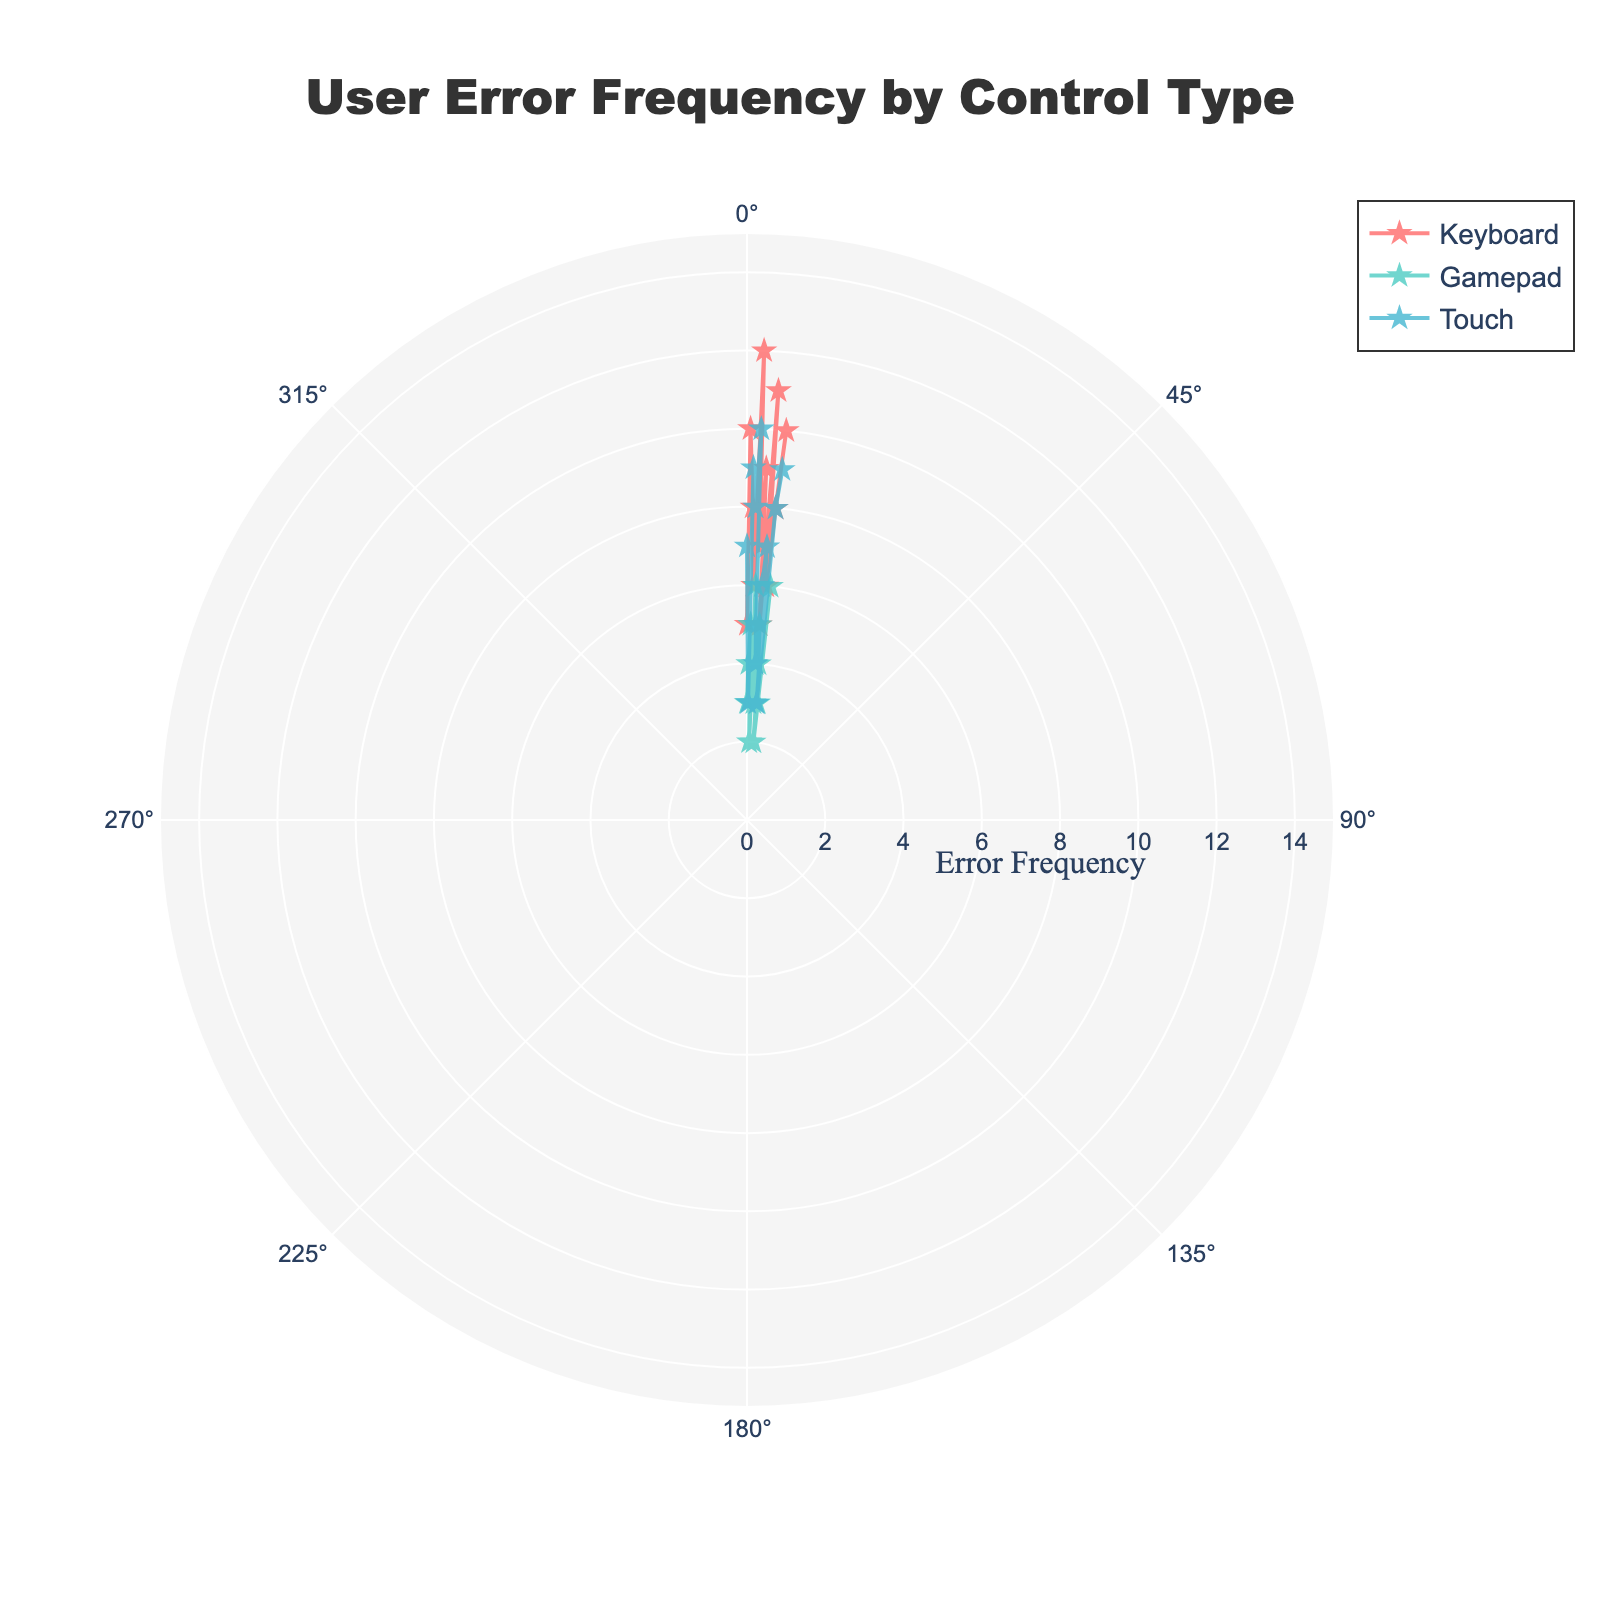What is the title of the figure? The title is usually placed prominently at the top center of the figure. It provides a quick summary of the chart's content.
Answer: User Error Frequency by Control Type Which control type has the highest error frequency at 90 degrees? To find this, look at the data points situated at the 90-degree mark for each control type. The highest value among these is the one with the most errors. Keyboard: 6, Gamepad: 2, Touch: 8.
Answer: Touch How many error frequency points are plotted for the Gamepad control type? Identify the color or symbol representing Gamepad, then count all the data points associated with it.
Answer: 12 What is the average error frequency for the Keyboard control type? Sum all the error frequencies for the Keyboard control type and divide by the number of data points for Keyboard. (5+10+8+6+12+7+9+5+11+6+8+10) / 12 = 97 / 12
Answer: 8.08 Which control type shows the least variation in error frequency? Variation can be judged by observing the spread of data points. The control type with tightly packed points indicates lower variation. Visually, Gamepad appears to have the least variation.
Answer: Gamepad What is the sum of error frequencies for the Touch control type at all angles? Add up all the error frequencies listed for the Touch control type. 7 + 3 + 9 + 8 + 10 + 5 + 4 + 6 + 7 + 3 + 8 + 9 = 79
Answer: 79 Which control type has the highest error frequency overall, and at which angle does it occur? Observe which data point has the maximum value and identify its associated control type and angle. The highest error frequency is 12 for Keyboard at 120 degrees.
Answer: Keyboard, 120 degrees At what angles do the Keyboard and Gamepad control types both have an error frequency of 6? Look for the points where Keyboard and Gamepad both have the same error frequency of 6. This occurs at Keyboard (120 and 270 degrees) and Gamepad (120 and 330 degrees).
Answer: 120 degrees Which control type error frequency crosses angular points with range from 150 to 270 degrees? Check each control type to see if they have data points between 150 to 270 degrees ranges. Keyboard: Yes, Gamepad: Yes, Touch: Yes.
Answer: All control types 